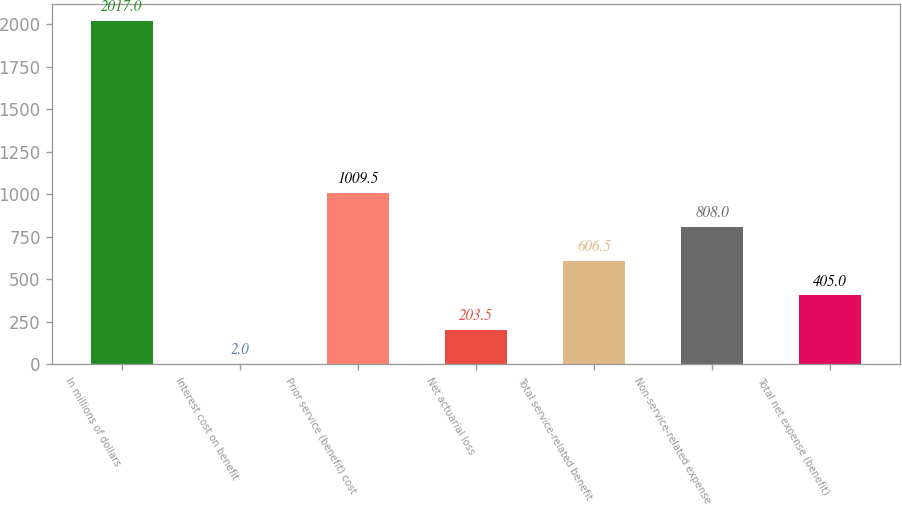<chart> <loc_0><loc_0><loc_500><loc_500><bar_chart><fcel>In millions of dollars<fcel>Interest cost on benefit<fcel>Prior service (benefit) cost<fcel>Net actuarial loss<fcel>Total service-related benefit<fcel>Non-service-related expense<fcel>Total net expense (benefit)<nl><fcel>2017<fcel>2<fcel>1009.5<fcel>203.5<fcel>606.5<fcel>808<fcel>405<nl></chart> 